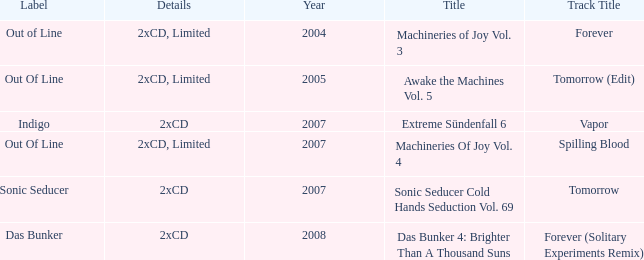Which track title has a year lesser thsn 2005? Forever. 